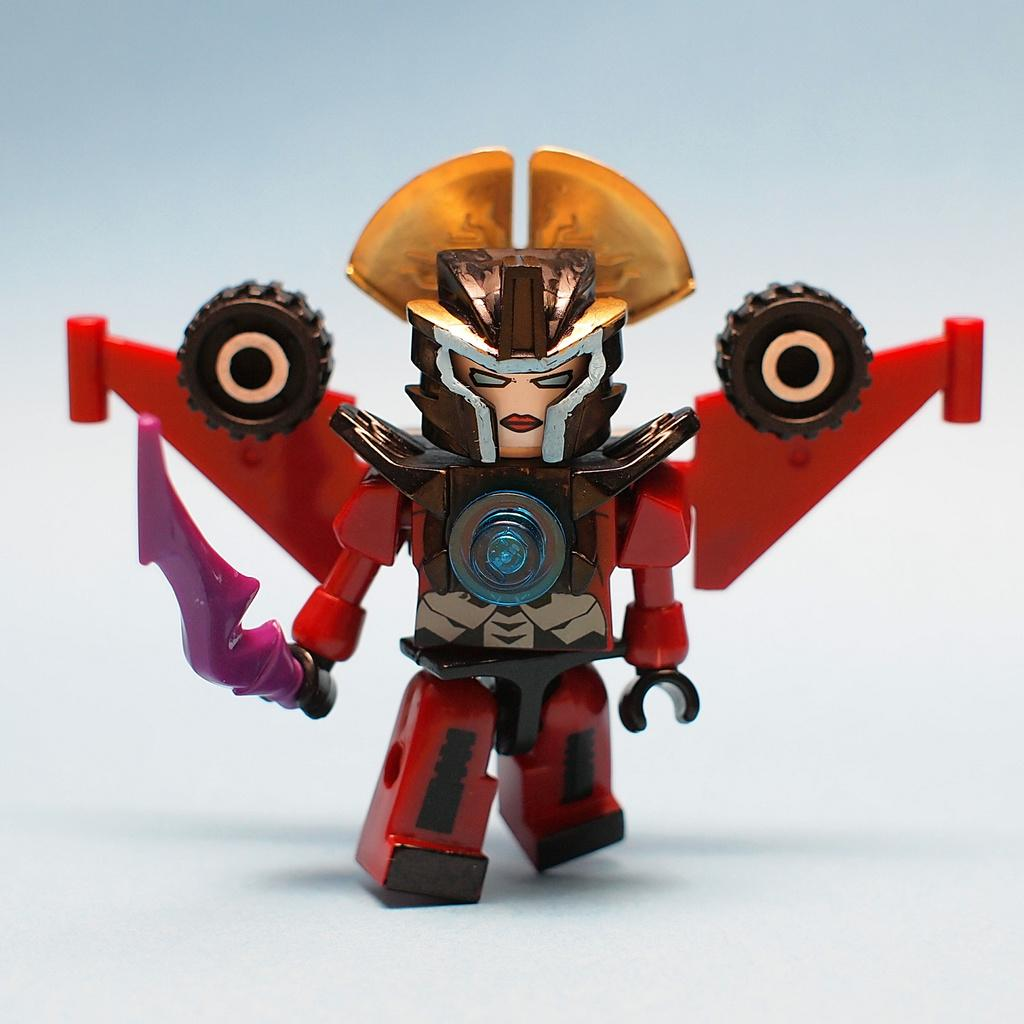What object can be seen in the image? There is a toy in the image. What is the color of the surface the toy is placed on? The toy is on a white surface. What time does the clock show in the image? There is no clock present in the image, so it is not possible to determine the time. 